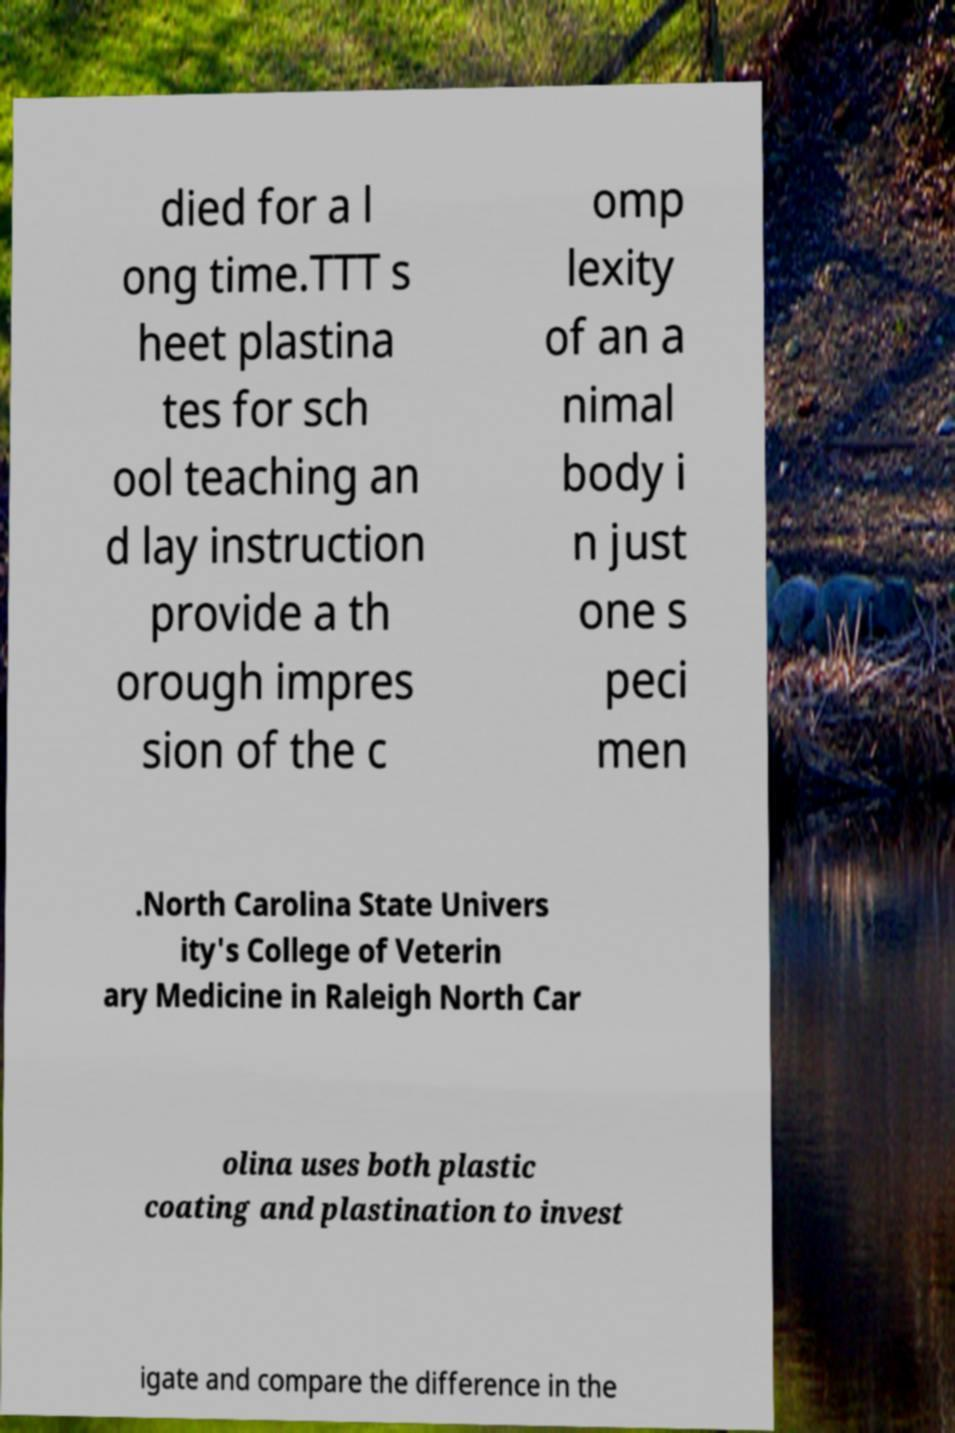Please identify and transcribe the text found in this image. died for a l ong time.TTT s heet plastina tes for sch ool teaching an d lay instruction provide a th orough impres sion of the c omp lexity of an a nimal body i n just one s peci men .North Carolina State Univers ity's College of Veterin ary Medicine in Raleigh North Car olina uses both plastic coating and plastination to invest igate and compare the difference in the 